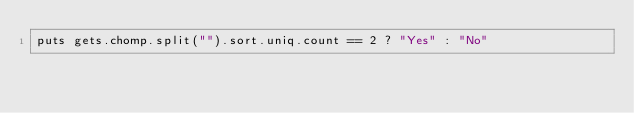<code> <loc_0><loc_0><loc_500><loc_500><_Ruby_>puts gets.chomp.split("").sort.uniq.count == 2 ? "Yes" : "No"
</code> 